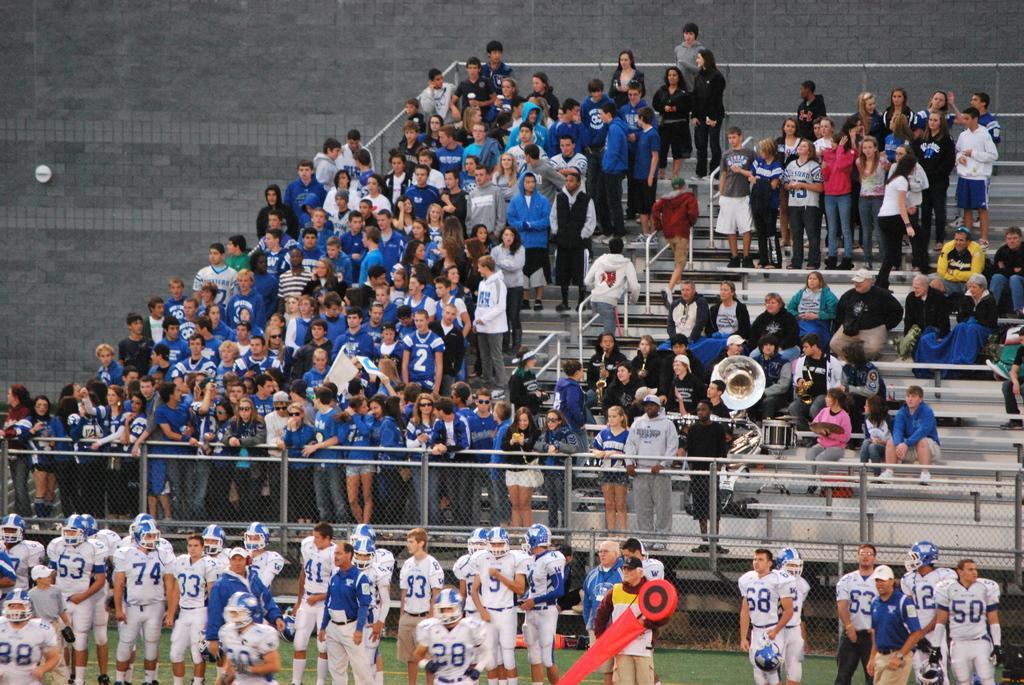Can you describe this image briefly? In this image, we can see a group of people. Few are standing and sitting. At the bottom, we can see a ground. Here there is a mesh with poles. Background we can see a wall, rods, stairs. Here a person is holding some red color object. 